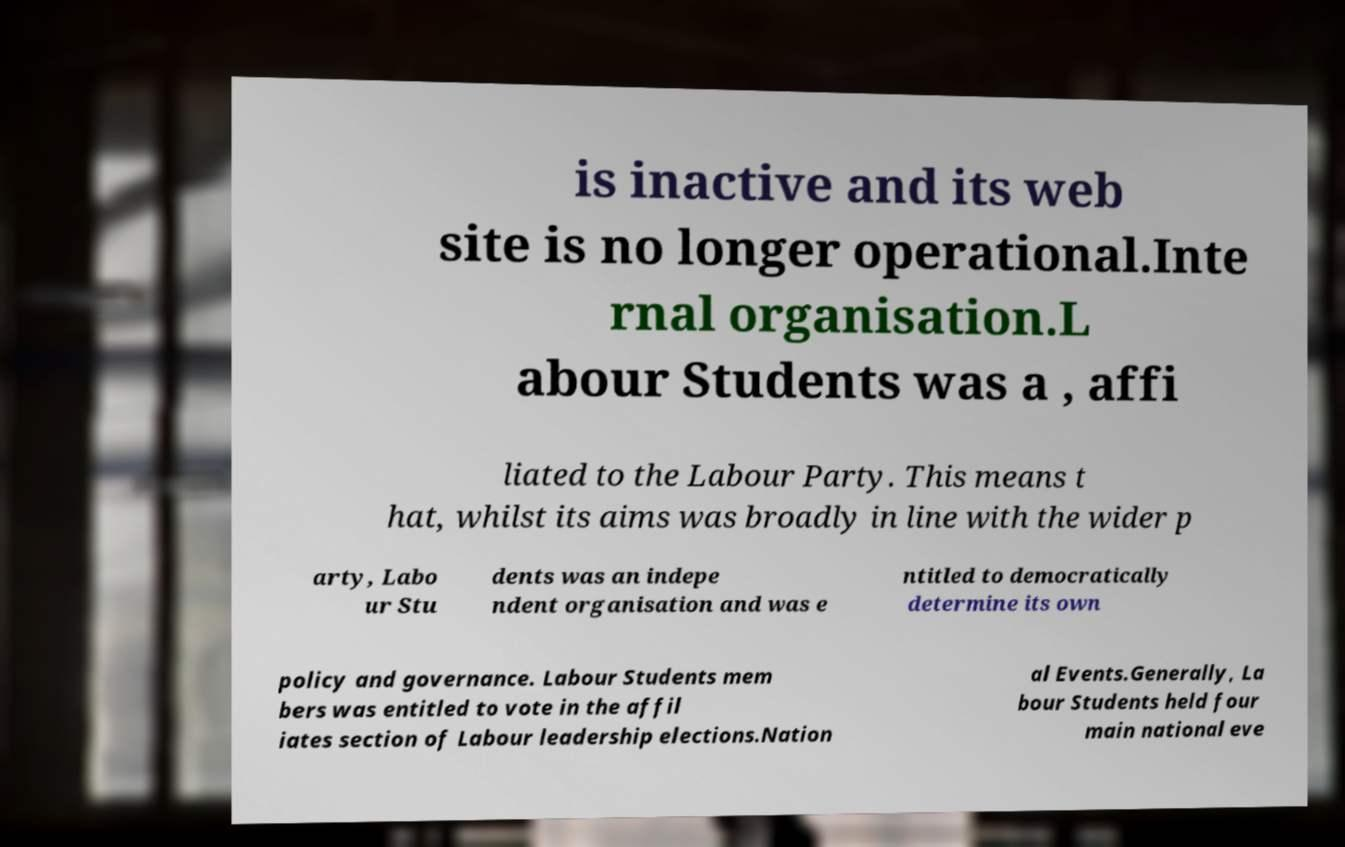There's text embedded in this image that I need extracted. Can you transcribe it verbatim? is inactive and its web site is no longer operational.Inte rnal organisation.L abour Students was a , affi liated to the Labour Party. This means t hat, whilst its aims was broadly in line with the wider p arty, Labo ur Stu dents was an indepe ndent organisation and was e ntitled to democratically determine its own policy and governance. Labour Students mem bers was entitled to vote in the affil iates section of Labour leadership elections.Nation al Events.Generally, La bour Students held four main national eve 